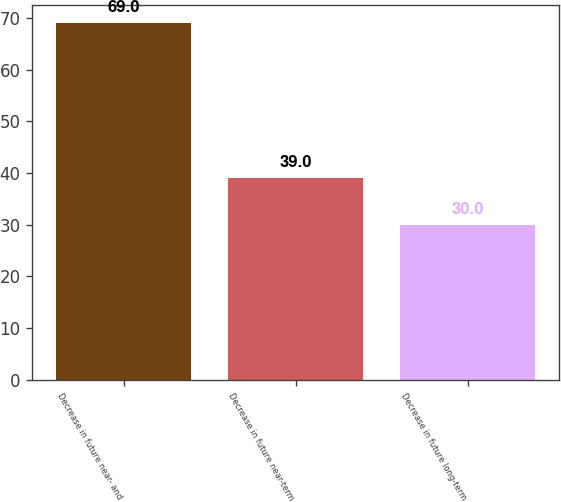<chart> <loc_0><loc_0><loc_500><loc_500><bar_chart><fcel>Decrease in future near- and<fcel>Decrease in future near-term<fcel>Decrease in future long-term<nl><fcel>69<fcel>39<fcel>30<nl></chart> 